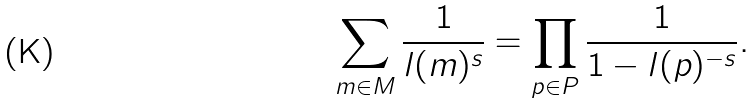Convert formula to latex. <formula><loc_0><loc_0><loc_500><loc_500>\sum _ { m \in M } \frac { 1 } { l ( m ) ^ { s } } = \prod _ { p \in P } \frac { 1 } { 1 - l ( p ) ^ { - s } } .</formula> 